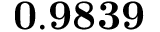Convert formula to latex. <formula><loc_0><loc_0><loc_500><loc_500>0 . 9 8 3 9</formula> 